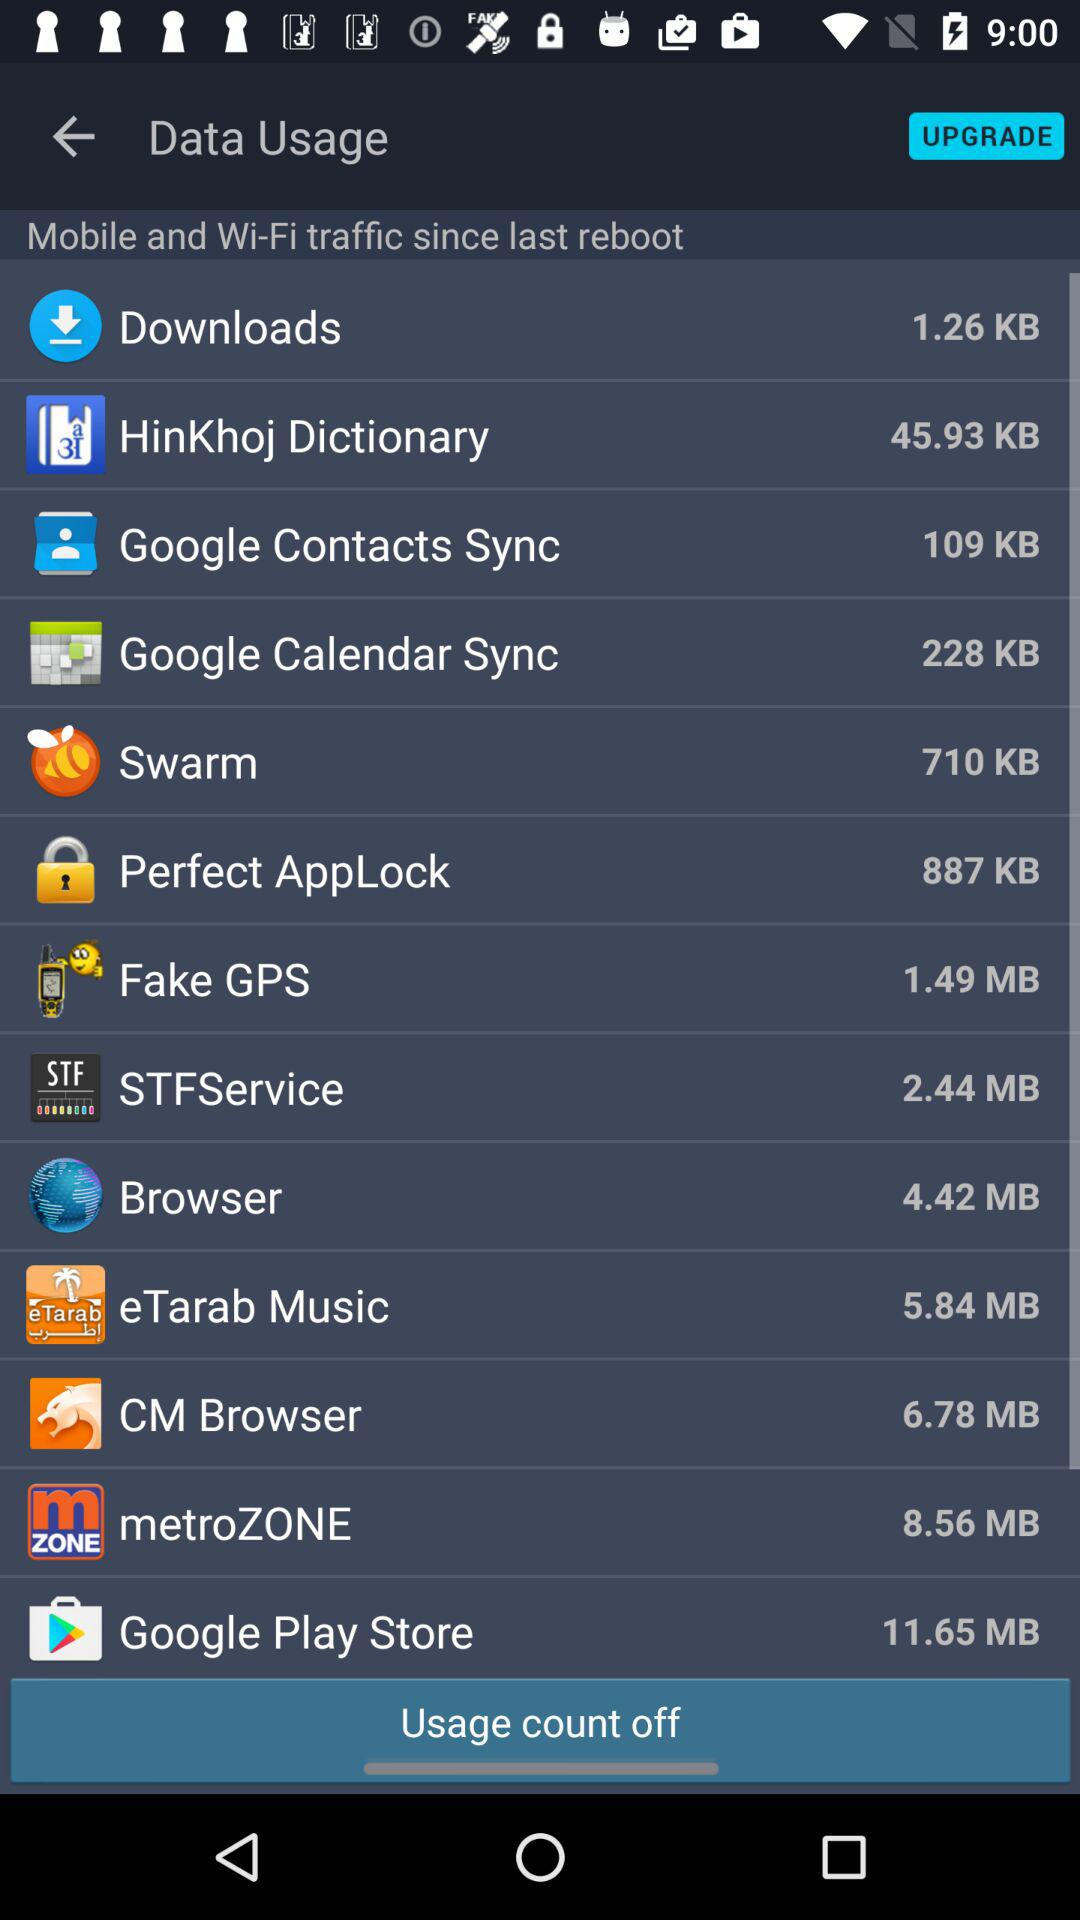How much data has been used for Google Play Store?
Answer the question using a single word or phrase. 11.65 MB 